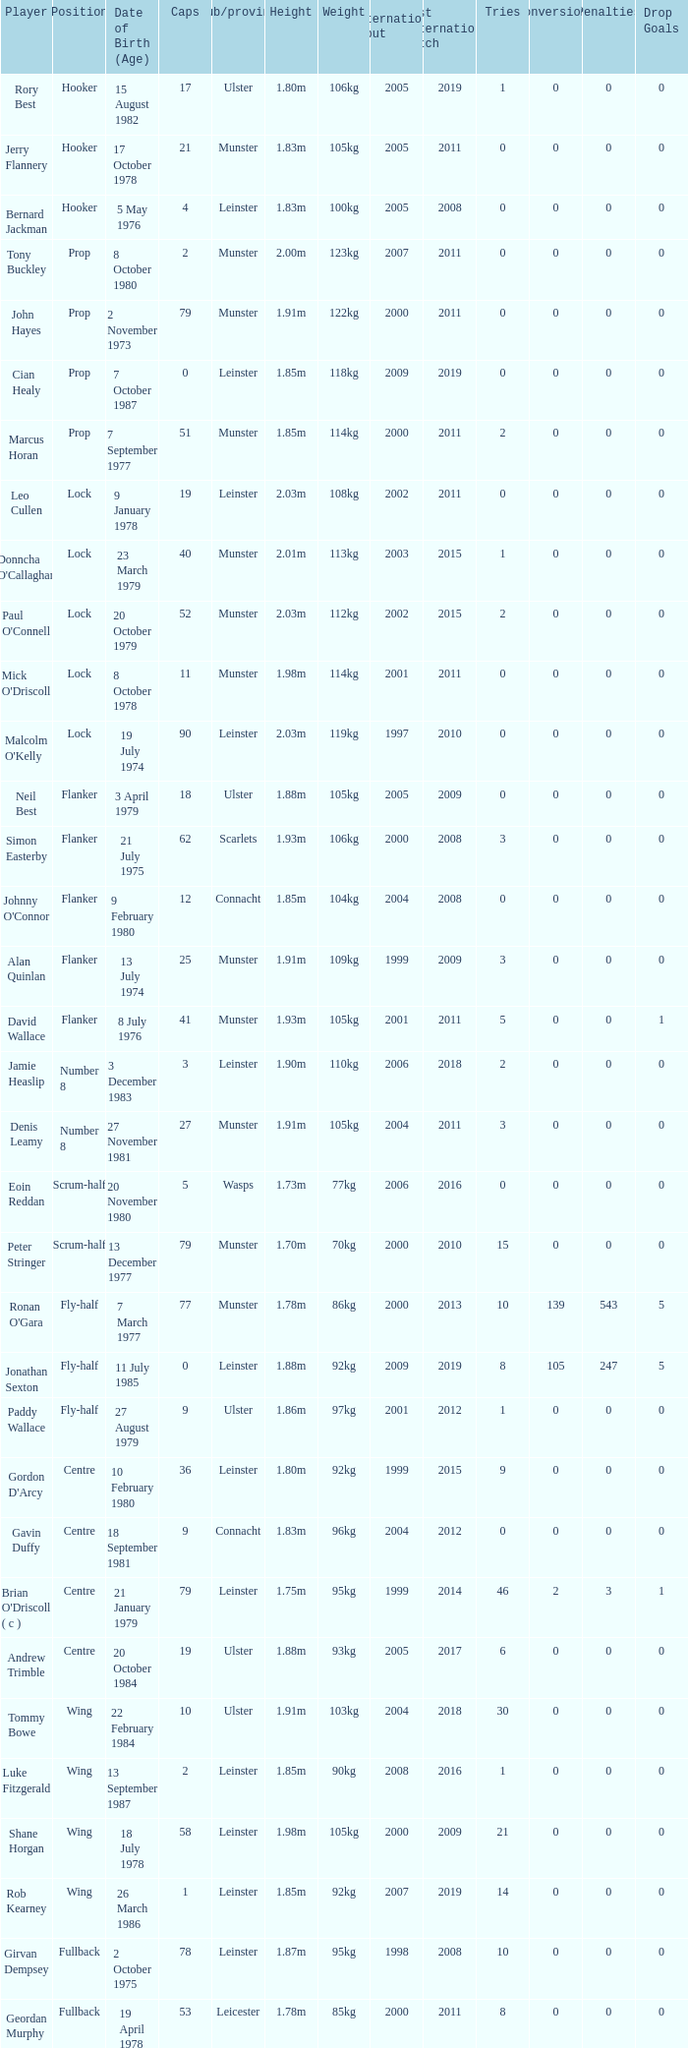How many Caps does the Club/province Munster, position of lock and Mick O'Driscoll have? 1.0. 